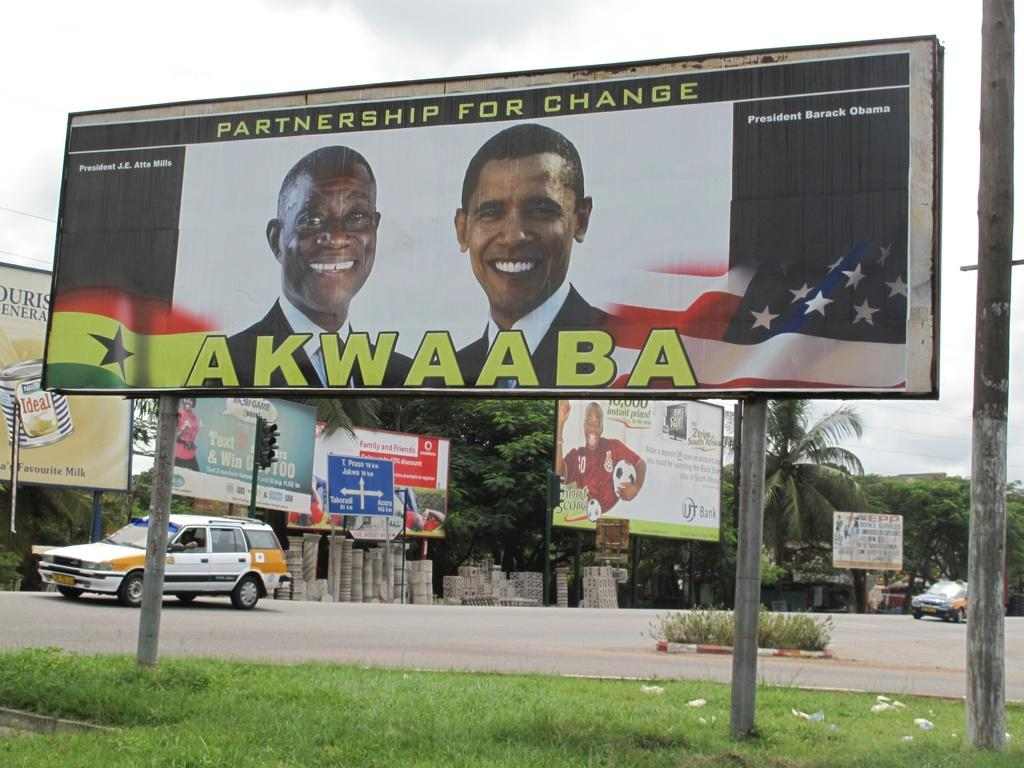<image>
Provide a brief description of the given image. A billboard with the words partnership for change appears above two politicians. 